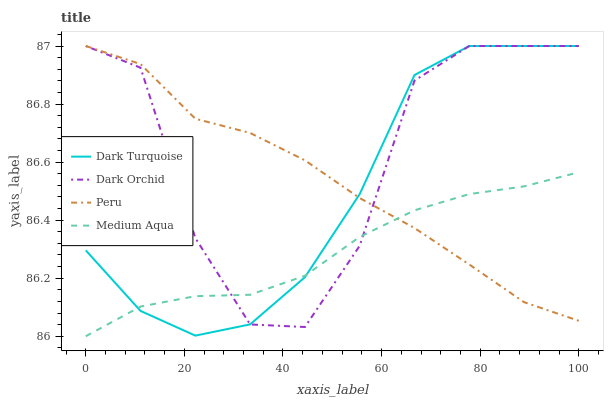Does Medium Aqua have the minimum area under the curve?
Answer yes or no. Yes. Does Dark Orchid have the maximum area under the curve?
Answer yes or no. Yes. Does Peru have the minimum area under the curve?
Answer yes or no. No. Does Peru have the maximum area under the curve?
Answer yes or no. No. Is Medium Aqua the smoothest?
Answer yes or no. Yes. Is Dark Orchid the roughest?
Answer yes or no. Yes. Is Peru the smoothest?
Answer yes or no. No. Is Peru the roughest?
Answer yes or no. No. Does Medium Aqua have the lowest value?
Answer yes or no. Yes. Does Peru have the lowest value?
Answer yes or no. No. Does Dark Orchid have the highest value?
Answer yes or no. Yes. Does Medium Aqua have the highest value?
Answer yes or no. No. Does Peru intersect Dark Turquoise?
Answer yes or no. Yes. Is Peru less than Dark Turquoise?
Answer yes or no. No. Is Peru greater than Dark Turquoise?
Answer yes or no. No. 